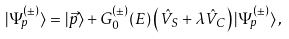<formula> <loc_0><loc_0><loc_500><loc_500>| \Psi _ { p } ^ { ( \pm ) } \rangle = | \vec { p } \rangle + G _ { 0 } ^ { ( \pm ) } ( E ) \left ( \hat { V } _ { S } + \lambda \hat { V } _ { C } \right ) | \Psi _ { p } ^ { ( \pm ) } \rangle \, ,</formula> 